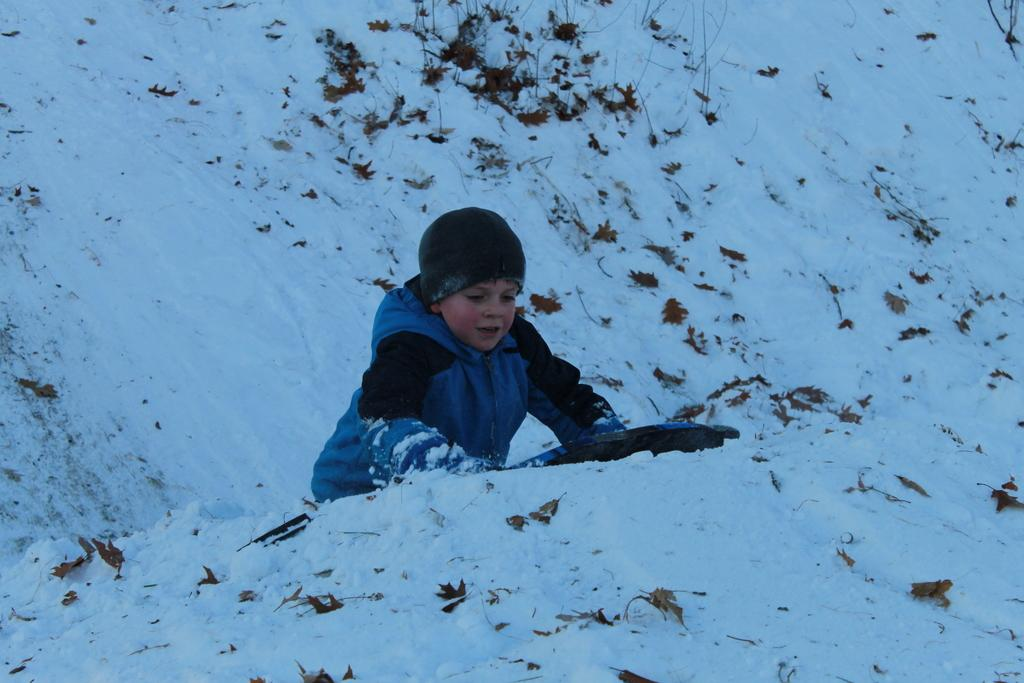Who is in the picture? There is a boy in the picture. What is the boy wearing on his head? The boy is wearing a cap. What type of clothing is the boy wearing on his upper body? The boy is wearing a jacket. What type of natural elements can be seen in the picture? There are dried leaves and twigs in the picture. What is the weather like in the picture? There is snow in the picture, indicating a cold or wintry environment. What type of punishment is the boy receiving in the picture? There is no indication of punishment in the image; the boy is simply wearing a cap and jacket while surrounded by dried leaves, twigs, and snow. What type of fuel is being used in the picture? There is no fuel or any indication of a fuel source in the image. 